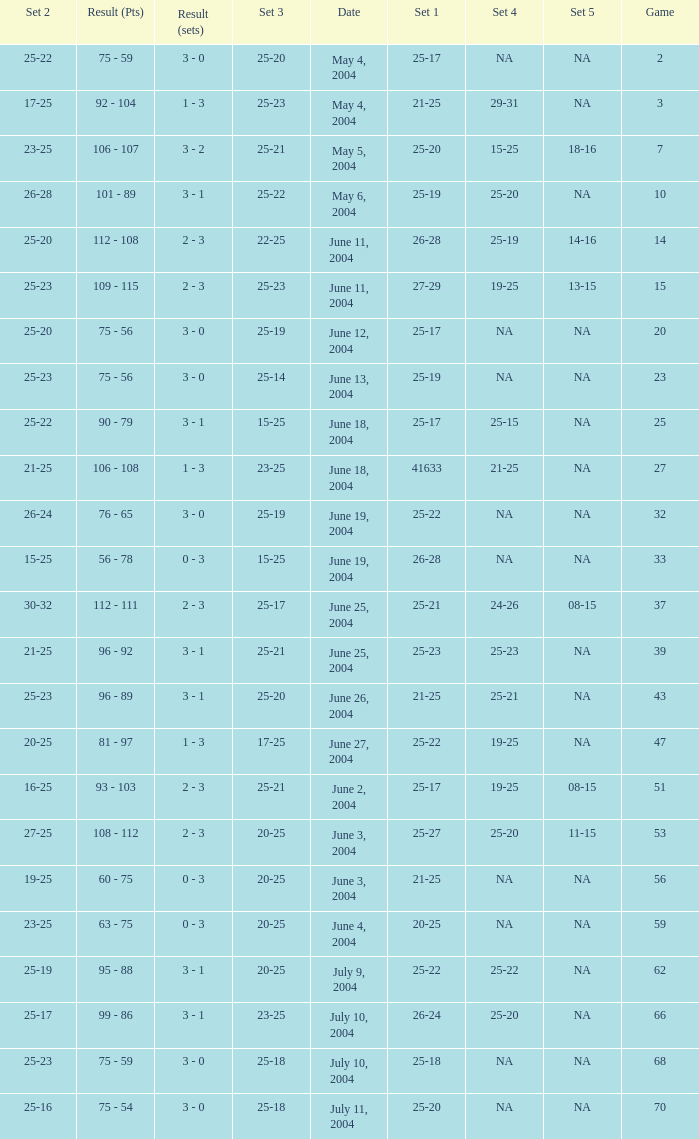What is the result of the game with a set 1 of 26-24? 99 - 86. 